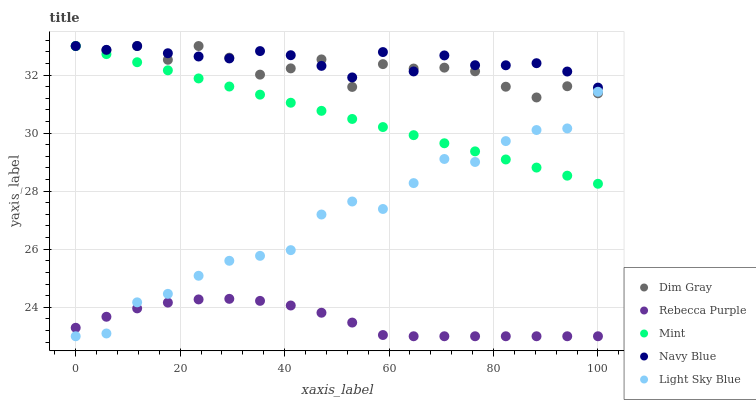Does Rebecca Purple have the minimum area under the curve?
Answer yes or no. Yes. Does Navy Blue have the maximum area under the curve?
Answer yes or no. Yes. Does Dim Gray have the minimum area under the curve?
Answer yes or no. No. Does Dim Gray have the maximum area under the curve?
Answer yes or no. No. Is Mint the smoothest?
Answer yes or no. Yes. Is Dim Gray the roughest?
Answer yes or no. Yes. Is Dim Gray the smoothest?
Answer yes or no. No. Is Mint the roughest?
Answer yes or no. No. Does Rebecca Purple have the lowest value?
Answer yes or no. Yes. Does Dim Gray have the lowest value?
Answer yes or no. No. Does Mint have the highest value?
Answer yes or no. Yes. Does Rebecca Purple have the highest value?
Answer yes or no. No. Is Rebecca Purple less than Navy Blue?
Answer yes or no. Yes. Is Dim Gray greater than Rebecca Purple?
Answer yes or no. Yes. Does Light Sky Blue intersect Dim Gray?
Answer yes or no. Yes. Is Light Sky Blue less than Dim Gray?
Answer yes or no. No. Is Light Sky Blue greater than Dim Gray?
Answer yes or no. No. Does Rebecca Purple intersect Navy Blue?
Answer yes or no. No. 